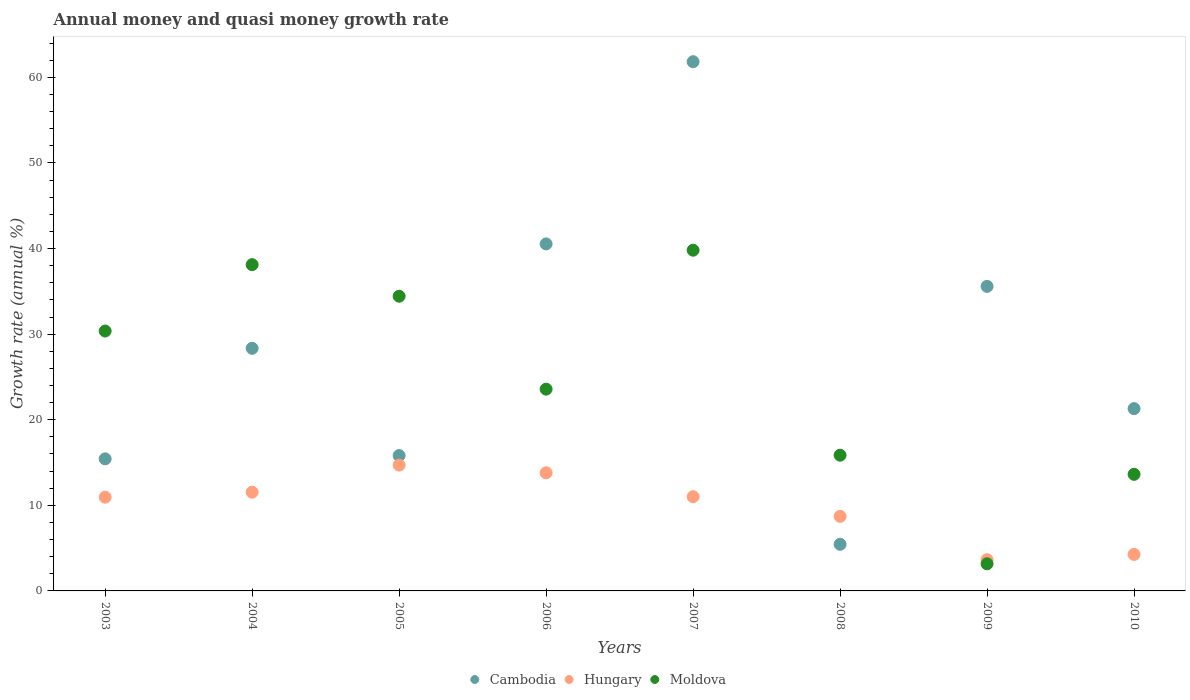Is the number of dotlines equal to the number of legend labels?
Provide a succinct answer. Yes. What is the growth rate in Moldova in 2006?
Your answer should be compact. 23.58. Across all years, what is the maximum growth rate in Cambodia?
Ensure brevity in your answer.  61.84. Across all years, what is the minimum growth rate in Hungary?
Keep it short and to the point. 3.65. In which year was the growth rate in Moldova minimum?
Your answer should be very brief. 2009. What is the total growth rate in Cambodia in the graph?
Keep it short and to the point. 224.31. What is the difference between the growth rate in Cambodia in 2006 and that in 2010?
Provide a succinct answer. 19.25. What is the difference between the growth rate in Hungary in 2009 and the growth rate in Moldova in 2008?
Give a very brief answer. -12.21. What is the average growth rate in Moldova per year?
Your answer should be very brief. 24.87. In the year 2005, what is the difference between the growth rate in Hungary and growth rate in Cambodia?
Ensure brevity in your answer.  -1.12. In how many years, is the growth rate in Moldova greater than 18 %?
Your answer should be very brief. 5. What is the ratio of the growth rate in Hungary in 2006 to that in 2010?
Your response must be concise. 3.23. What is the difference between the highest and the second highest growth rate in Moldova?
Give a very brief answer. 1.69. What is the difference between the highest and the lowest growth rate in Cambodia?
Your response must be concise. 56.39. Is the sum of the growth rate in Moldova in 2003 and 2010 greater than the maximum growth rate in Cambodia across all years?
Your answer should be very brief. No. Does the growth rate in Cambodia monotonically increase over the years?
Your answer should be compact. No. How many dotlines are there?
Keep it short and to the point. 3. Are the values on the major ticks of Y-axis written in scientific E-notation?
Keep it short and to the point. No. Where does the legend appear in the graph?
Ensure brevity in your answer.  Bottom center. What is the title of the graph?
Your answer should be compact. Annual money and quasi money growth rate. Does "Suriname" appear as one of the legend labels in the graph?
Ensure brevity in your answer.  No. What is the label or title of the Y-axis?
Make the answer very short. Growth rate (annual %). What is the Growth rate (annual %) in Cambodia in 2003?
Offer a terse response. 15.43. What is the Growth rate (annual %) of Hungary in 2003?
Make the answer very short. 10.95. What is the Growth rate (annual %) in Moldova in 2003?
Keep it short and to the point. 30.37. What is the Growth rate (annual %) of Cambodia in 2004?
Keep it short and to the point. 28.35. What is the Growth rate (annual %) in Hungary in 2004?
Ensure brevity in your answer.  11.54. What is the Growth rate (annual %) in Moldova in 2004?
Provide a succinct answer. 38.12. What is the Growth rate (annual %) in Cambodia in 2005?
Your answer should be compact. 15.82. What is the Growth rate (annual %) in Hungary in 2005?
Offer a terse response. 14.7. What is the Growth rate (annual %) in Moldova in 2005?
Keep it short and to the point. 34.43. What is the Growth rate (annual %) in Cambodia in 2006?
Ensure brevity in your answer.  40.55. What is the Growth rate (annual %) in Hungary in 2006?
Keep it short and to the point. 13.8. What is the Growth rate (annual %) in Moldova in 2006?
Provide a short and direct response. 23.58. What is the Growth rate (annual %) of Cambodia in 2007?
Your response must be concise. 61.84. What is the Growth rate (annual %) of Hungary in 2007?
Offer a very short reply. 11.01. What is the Growth rate (annual %) of Moldova in 2007?
Offer a very short reply. 39.81. What is the Growth rate (annual %) in Cambodia in 2008?
Ensure brevity in your answer.  5.45. What is the Growth rate (annual %) in Hungary in 2008?
Offer a very short reply. 8.71. What is the Growth rate (annual %) of Moldova in 2008?
Provide a short and direct response. 15.86. What is the Growth rate (annual %) of Cambodia in 2009?
Your answer should be compact. 35.58. What is the Growth rate (annual %) in Hungary in 2009?
Your answer should be very brief. 3.65. What is the Growth rate (annual %) of Moldova in 2009?
Give a very brief answer. 3.17. What is the Growth rate (annual %) in Cambodia in 2010?
Provide a succinct answer. 21.3. What is the Growth rate (annual %) in Hungary in 2010?
Your answer should be very brief. 4.27. What is the Growth rate (annual %) of Moldova in 2010?
Provide a succinct answer. 13.62. Across all years, what is the maximum Growth rate (annual %) of Cambodia?
Your answer should be compact. 61.84. Across all years, what is the maximum Growth rate (annual %) in Hungary?
Offer a terse response. 14.7. Across all years, what is the maximum Growth rate (annual %) in Moldova?
Offer a terse response. 39.81. Across all years, what is the minimum Growth rate (annual %) in Cambodia?
Keep it short and to the point. 5.45. Across all years, what is the minimum Growth rate (annual %) of Hungary?
Your answer should be very brief. 3.65. Across all years, what is the minimum Growth rate (annual %) of Moldova?
Ensure brevity in your answer.  3.17. What is the total Growth rate (annual %) in Cambodia in the graph?
Offer a terse response. 224.31. What is the total Growth rate (annual %) in Hungary in the graph?
Offer a very short reply. 78.63. What is the total Growth rate (annual %) of Moldova in the graph?
Your response must be concise. 198.96. What is the difference between the Growth rate (annual %) in Cambodia in 2003 and that in 2004?
Your answer should be very brief. -12.92. What is the difference between the Growth rate (annual %) in Hungary in 2003 and that in 2004?
Give a very brief answer. -0.59. What is the difference between the Growth rate (annual %) of Moldova in 2003 and that in 2004?
Your answer should be very brief. -7.76. What is the difference between the Growth rate (annual %) of Cambodia in 2003 and that in 2005?
Ensure brevity in your answer.  -0.38. What is the difference between the Growth rate (annual %) of Hungary in 2003 and that in 2005?
Provide a short and direct response. -3.75. What is the difference between the Growth rate (annual %) in Moldova in 2003 and that in 2005?
Make the answer very short. -4.07. What is the difference between the Growth rate (annual %) in Cambodia in 2003 and that in 2006?
Provide a succinct answer. -25.11. What is the difference between the Growth rate (annual %) of Hungary in 2003 and that in 2006?
Ensure brevity in your answer.  -2.85. What is the difference between the Growth rate (annual %) in Moldova in 2003 and that in 2006?
Provide a succinct answer. 6.79. What is the difference between the Growth rate (annual %) of Cambodia in 2003 and that in 2007?
Your response must be concise. -46.4. What is the difference between the Growth rate (annual %) of Hungary in 2003 and that in 2007?
Your response must be concise. -0.06. What is the difference between the Growth rate (annual %) in Moldova in 2003 and that in 2007?
Keep it short and to the point. -9.44. What is the difference between the Growth rate (annual %) in Cambodia in 2003 and that in 2008?
Offer a very short reply. 9.99. What is the difference between the Growth rate (annual %) of Hungary in 2003 and that in 2008?
Ensure brevity in your answer.  2.24. What is the difference between the Growth rate (annual %) in Moldova in 2003 and that in 2008?
Offer a terse response. 14.51. What is the difference between the Growth rate (annual %) of Cambodia in 2003 and that in 2009?
Make the answer very short. -20.15. What is the difference between the Growth rate (annual %) of Hungary in 2003 and that in 2009?
Ensure brevity in your answer.  7.3. What is the difference between the Growth rate (annual %) of Moldova in 2003 and that in 2009?
Provide a succinct answer. 27.2. What is the difference between the Growth rate (annual %) in Cambodia in 2003 and that in 2010?
Provide a short and direct response. -5.87. What is the difference between the Growth rate (annual %) in Hungary in 2003 and that in 2010?
Make the answer very short. 6.69. What is the difference between the Growth rate (annual %) of Moldova in 2003 and that in 2010?
Give a very brief answer. 16.74. What is the difference between the Growth rate (annual %) of Cambodia in 2004 and that in 2005?
Your answer should be very brief. 12.53. What is the difference between the Growth rate (annual %) in Hungary in 2004 and that in 2005?
Provide a succinct answer. -3.16. What is the difference between the Growth rate (annual %) of Moldova in 2004 and that in 2005?
Offer a terse response. 3.69. What is the difference between the Growth rate (annual %) of Cambodia in 2004 and that in 2006?
Ensure brevity in your answer.  -12.2. What is the difference between the Growth rate (annual %) in Hungary in 2004 and that in 2006?
Make the answer very short. -2.27. What is the difference between the Growth rate (annual %) in Moldova in 2004 and that in 2006?
Provide a succinct answer. 14.55. What is the difference between the Growth rate (annual %) in Cambodia in 2004 and that in 2007?
Make the answer very short. -33.49. What is the difference between the Growth rate (annual %) of Hungary in 2004 and that in 2007?
Ensure brevity in your answer.  0.53. What is the difference between the Growth rate (annual %) of Moldova in 2004 and that in 2007?
Provide a succinct answer. -1.69. What is the difference between the Growth rate (annual %) of Cambodia in 2004 and that in 2008?
Your answer should be very brief. 22.9. What is the difference between the Growth rate (annual %) of Hungary in 2004 and that in 2008?
Your response must be concise. 2.83. What is the difference between the Growth rate (annual %) in Moldova in 2004 and that in 2008?
Your answer should be very brief. 22.26. What is the difference between the Growth rate (annual %) in Cambodia in 2004 and that in 2009?
Offer a terse response. -7.23. What is the difference between the Growth rate (annual %) in Hungary in 2004 and that in 2009?
Ensure brevity in your answer.  7.89. What is the difference between the Growth rate (annual %) of Moldova in 2004 and that in 2009?
Provide a succinct answer. 34.95. What is the difference between the Growth rate (annual %) in Cambodia in 2004 and that in 2010?
Provide a short and direct response. 7.05. What is the difference between the Growth rate (annual %) of Hungary in 2004 and that in 2010?
Make the answer very short. 7.27. What is the difference between the Growth rate (annual %) in Moldova in 2004 and that in 2010?
Your answer should be compact. 24.5. What is the difference between the Growth rate (annual %) of Cambodia in 2005 and that in 2006?
Provide a succinct answer. -24.73. What is the difference between the Growth rate (annual %) in Hungary in 2005 and that in 2006?
Ensure brevity in your answer.  0.9. What is the difference between the Growth rate (annual %) in Moldova in 2005 and that in 2006?
Make the answer very short. 10.86. What is the difference between the Growth rate (annual %) of Cambodia in 2005 and that in 2007?
Keep it short and to the point. -46.02. What is the difference between the Growth rate (annual %) of Hungary in 2005 and that in 2007?
Ensure brevity in your answer.  3.69. What is the difference between the Growth rate (annual %) of Moldova in 2005 and that in 2007?
Make the answer very short. -5.38. What is the difference between the Growth rate (annual %) in Cambodia in 2005 and that in 2008?
Your response must be concise. 10.37. What is the difference between the Growth rate (annual %) in Hungary in 2005 and that in 2008?
Ensure brevity in your answer.  5.99. What is the difference between the Growth rate (annual %) of Moldova in 2005 and that in 2008?
Offer a terse response. 18.57. What is the difference between the Growth rate (annual %) of Cambodia in 2005 and that in 2009?
Your response must be concise. -19.77. What is the difference between the Growth rate (annual %) of Hungary in 2005 and that in 2009?
Ensure brevity in your answer.  11.05. What is the difference between the Growth rate (annual %) of Moldova in 2005 and that in 2009?
Your answer should be compact. 31.27. What is the difference between the Growth rate (annual %) of Cambodia in 2005 and that in 2010?
Make the answer very short. -5.48. What is the difference between the Growth rate (annual %) of Hungary in 2005 and that in 2010?
Your answer should be very brief. 10.43. What is the difference between the Growth rate (annual %) of Moldova in 2005 and that in 2010?
Make the answer very short. 20.81. What is the difference between the Growth rate (annual %) in Cambodia in 2006 and that in 2007?
Make the answer very short. -21.29. What is the difference between the Growth rate (annual %) in Hungary in 2006 and that in 2007?
Offer a very short reply. 2.79. What is the difference between the Growth rate (annual %) in Moldova in 2006 and that in 2007?
Your answer should be compact. -16.23. What is the difference between the Growth rate (annual %) in Cambodia in 2006 and that in 2008?
Give a very brief answer. 35.1. What is the difference between the Growth rate (annual %) in Hungary in 2006 and that in 2008?
Offer a very short reply. 5.09. What is the difference between the Growth rate (annual %) in Moldova in 2006 and that in 2008?
Offer a terse response. 7.72. What is the difference between the Growth rate (annual %) of Cambodia in 2006 and that in 2009?
Your answer should be compact. 4.96. What is the difference between the Growth rate (annual %) in Hungary in 2006 and that in 2009?
Ensure brevity in your answer.  10.15. What is the difference between the Growth rate (annual %) of Moldova in 2006 and that in 2009?
Give a very brief answer. 20.41. What is the difference between the Growth rate (annual %) of Cambodia in 2006 and that in 2010?
Your response must be concise. 19.25. What is the difference between the Growth rate (annual %) in Hungary in 2006 and that in 2010?
Make the answer very short. 9.54. What is the difference between the Growth rate (annual %) of Moldova in 2006 and that in 2010?
Ensure brevity in your answer.  9.95. What is the difference between the Growth rate (annual %) of Cambodia in 2007 and that in 2008?
Keep it short and to the point. 56.39. What is the difference between the Growth rate (annual %) in Hungary in 2007 and that in 2008?
Keep it short and to the point. 2.3. What is the difference between the Growth rate (annual %) in Moldova in 2007 and that in 2008?
Provide a short and direct response. 23.95. What is the difference between the Growth rate (annual %) of Cambodia in 2007 and that in 2009?
Offer a terse response. 26.25. What is the difference between the Growth rate (annual %) of Hungary in 2007 and that in 2009?
Your answer should be very brief. 7.36. What is the difference between the Growth rate (annual %) of Moldova in 2007 and that in 2009?
Keep it short and to the point. 36.64. What is the difference between the Growth rate (annual %) of Cambodia in 2007 and that in 2010?
Your answer should be very brief. 40.54. What is the difference between the Growth rate (annual %) of Hungary in 2007 and that in 2010?
Provide a succinct answer. 6.74. What is the difference between the Growth rate (annual %) of Moldova in 2007 and that in 2010?
Provide a succinct answer. 26.19. What is the difference between the Growth rate (annual %) in Cambodia in 2008 and that in 2009?
Your response must be concise. -30.14. What is the difference between the Growth rate (annual %) in Hungary in 2008 and that in 2009?
Give a very brief answer. 5.06. What is the difference between the Growth rate (annual %) of Moldova in 2008 and that in 2009?
Give a very brief answer. 12.69. What is the difference between the Growth rate (annual %) of Cambodia in 2008 and that in 2010?
Your answer should be very brief. -15.85. What is the difference between the Growth rate (annual %) of Hungary in 2008 and that in 2010?
Offer a terse response. 4.44. What is the difference between the Growth rate (annual %) of Moldova in 2008 and that in 2010?
Offer a terse response. 2.24. What is the difference between the Growth rate (annual %) in Cambodia in 2009 and that in 2010?
Give a very brief answer. 14.28. What is the difference between the Growth rate (annual %) of Hungary in 2009 and that in 2010?
Make the answer very short. -0.62. What is the difference between the Growth rate (annual %) in Moldova in 2009 and that in 2010?
Ensure brevity in your answer.  -10.45. What is the difference between the Growth rate (annual %) in Cambodia in 2003 and the Growth rate (annual %) in Hungary in 2004?
Make the answer very short. 3.89. What is the difference between the Growth rate (annual %) in Cambodia in 2003 and the Growth rate (annual %) in Moldova in 2004?
Your answer should be compact. -22.69. What is the difference between the Growth rate (annual %) in Hungary in 2003 and the Growth rate (annual %) in Moldova in 2004?
Give a very brief answer. -27.17. What is the difference between the Growth rate (annual %) of Cambodia in 2003 and the Growth rate (annual %) of Hungary in 2005?
Make the answer very short. 0.73. What is the difference between the Growth rate (annual %) in Cambodia in 2003 and the Growth rate (annual %) in Moldova in 2005?
Provide a short and direct response. -19. What is the difference between the Growth rate (annual %) of Hungary in 2003 and the Growth rate (annual %) of Moldova in 2005?
Give a very brief answer. -23.48. What is the difference between the Growth rate (annual %) in Cambodia in 2003 and the Growth rate (annual %) in Hungary in 2006?
Provide a short and direct response. 1.63. What is the difference between the Growth rate (annual %) in Cambodia in 2003 and the Growth rate (annual %) in Moldova in 2006?
Provide a short and direct response. -8.14. What is the difference between the Growth rate (annual %) of Hungary in 2003 and the Growth rate (annual %) of Moldova in 2006?
Provide a succinct answer. -12.62. What is the difference between the Growth rate (annual %) of Cambodia in 2003 and the Growth rate (annual %) of Hungary in 2007?
Your answer should be compact. 4.42. What is the difference between the Growth rate (annual %) of Cambodia in 2003 and the Growth rate (annual %) of Moldova in 2007?
Make the answer very short. -24.38. What is the difference between the Growth rate (annual %) in Hungary in 2003 and the Growth rate (annual %) in Moldova in 2007?
Offer a terse response. -28.86. What is the difference between the Growth rate (annual %) in Cambodia in 2003 and the Growth rate (annual %) in Hungary in 2008?
Ensure brevity in your answer.  6.72. What is the difference between the Growth rate (annual %) of Cambodia in 2003 and the Growth rate (annual %) of Moldova in 2008?
Give a very brief answer. -0.43. What is the difference between the Growth rate (annual %) in Hungary in 2003 and the Growth rate (annual %) in Moldova in 2008?
Ensure brevity in your answer.  -4.91. What is the difference between the Growth rate (annual %) of Cambodia in 2003 and the Growth rate (annual %) of Hungary in 2009?
Your answer should be very brief. 11.78. What is the difference between the Growth rate (annual %) in Cambodia in 2003 and the Growth rate (annual %) in Moldova in 2009?
Your answer should be compact. 12.26. What is the difference between the Growth rate (annual %) of Hungary in 2003 and the Growth rate (annual %) of Moldova in 2009?
Give a very brief answer. 7.78. What is the difference between the Growth rate (annual %) of Cambodia in 2003 and the Growth rate (annual %) of Hungary in 2010?
Your answer should be compact. 11.17. What is the difference between the Growth rate (annual %) in Cambodia in 2003 and the Growth rate (annual %) in Moldova in 2010?
Your answer should be compact. 1.81. What is the difference between the Growth rate (annual %) of Hungary in 2003 and the Growth rate (annual %) of Moldova in 2010?
Ensure brevity in your answer.  -2.67. What is the difference between the Growth rate (annual %) in Cambodia in 2004 and the Growth rate (annual %) in Hungary in 2005?
Provide a succinct answer. 13.65. What is the difference between the Growth rate (annual %) of Cambodia in 2004 and the Growth rate (annual %) of Moldova in 2005?
Your answer should be compact. -6.08. What is the difference between the Growth rate (annual %) of Hungary in 2004 and the Growth rate (annual %) of Moldova in 2005?
Make the answer very short. -22.9. What is the difference between the Growth rate (annual %) in Cambodia in 2004 and the Growth rate (annual %) in Hungary in 2006?
Offer a terse response. 14.55. What is the difference between the Growth rate (annual %) in Cambodia in 2004 and the Growth rate (annual %) in Moldova in 2006?
Keep it short and to the point. 4.77. What is the difference between the Growth rate (annual %) in Hungary in 2004 and the Growth rate (annual %) in Moldova in 2006?
Keep it short and to the point. -12.04. What is the difference between the Growth rate (annual %) of Cambodia in 2004 and the Growth rate (annual %) of Hungary in 2007?
Provide a succinct answer. 17.34. What is the difference between the Growth rate (annual %) of Cambodia in 2004 and the Growth rate (annual %) of Moldova in 2007?
Give a very brief answer. -11.46. What is the difference between the Growth rate (annual %) in Hungary in 2004 and the Growth rate (annual %) in Moldova in 2007?
Provide a short and direct response. -28.27. What is the difference between the Growth rate (annual %) of Cambodia in 2004 and the Growth rate (annual %) of Hungary in 2008?
Your answer should be very brief. 19.64. What is the difference between the Growth rate (annual %) in Cambodia in 2004 and the Growth rate (annual %) in Moldova in 2008?
Ensure brevity in your answer.  12.49. What is the difference between the Growth rate (annual %) of Hungary in 2004 and the Growth rate (annual %) of Moldova in 2008?
Your response must be concise. -4.32. What is the difference between the Growth rate (annual %) of Cambodia in 2004 and the Growth rate (annual %) of Hungary in 2009?
Keep it short and to the point. 24.7. What is the difference between the Growth rate (annual %) in Cambodia in 2004 and the Growth rate (annual %) in Moldova in 2009?
Your answer should be compact. 25.18. What is the difference between the Growth rate (annual %) of Hungary in 2004 and the Growth rate (annual %) of Moldova in 2009?
Give a very brief answer. 8.37. What is the difference between the Growth rate (annual %) of Cambodia in 2004 and the Growth rate (annual %) of Hungary in 2010?
Give a very brief answer. 24.08. What is the difference between the Growth rate (annual %) in Cambodia in 2004 and the Growth rate (annual %) in Moldova in 2010?
Offer a terse response. 14.73. What is the difference between the Growth rate (annual %) of Hungary in 2004 and the Growth rate (annual %) of Moldova in 2010?
Provide a short and direct response. -2.08. What is the difference between the Growth rate (annual %) of Cambodia in 2005 and the Growth rate (annual %) of Hungary in 2006?
Your response must be concise. 2.01. What is the difference between the Growth rate (annual %) in Cambodia in 2005 and the Growth rate (annual %) in Moldova in 2006?
Ensure brevity in your answer.  -7.76. What is the difference between the Growth rate (annual %) of Hungary in 2005 and the Growth rate (annual %) of Moldova in 2006?
Provide a succinct answer. -8.88. What is the difference between the Growth rate (annual %) in Cambodia in 2005 and the Growth rate (annual %) in Hungary in 2007?
Give a very brief answer. 4.8. What is the difference between the Growth rate (annual %) of Cambodia in 2005 and the Growth rate (annual %) of Moldova in 2007?
Your answer should be very brief. -23.99. What is the difference between the Growth rate (annual %) of Hungary in 2005 and the Growth rate (annual %) of Moldova in 2007?
Your answer should be very brief. -25.11. What is the difference between the Growth rate (annual %) of Cambodia in 2005 and the Growth rate (annual %) of Hungary in 2008?
Your answer should be compact. 7.11. What is the difference between the Growth rate (annual %) in Cambodia in 2005 and the Growth rate (annual %) in Moldova in 2008?
Ensure brevity in your answer.  -0.04. What is the difference between the Growth rate (annual %) of Hungary in 2005 and the Growth rate (annual %) of Moldova in 2008?
Your answer should be very brief. -1.16. What is the difference between the Growth rate (annual %) of Cambodia in 2005 and the Growth rate (annual %) of Hungary in 2009?
Your response must be concise. 12.17. What is the difference between the Growth rate (annual %) of Cambodia in 2005 and the Growth rate (annual %) of Moldova in 2009?
Provide a short and direct response. 12.65. What is the difference between the Growth rate (annual %) of Hungary in 2005 and the Growth rate (annual %) of Moldova in 2009?
Provide a succinct answer. 11.53. What is the difference between the Growth rate (annual %) in Cambodia in 2005 and the Growth rate (annual %) in Hungary in 2010?
Your answer should be very brief. 11.55. What is the difference between the Growth rate (annual %) of Cambodia in 2005 and the Growth rate (annual %) of Moldova in 2010?
Provide a short and direct response. 2.19. What is the difference between the Growth rate (annual %) in Hungary in 2005 and the Growth rate (annual %) in Moldova in 2010?
Provide a succinct answer. 1.08. What is the difference between the Growth rate (annual %) in Cambodia in 2006 and the Growth rate (annual %) in Hungary in 2007?
Offer a terse response. 29.53. What is the difference between the Growth rate (annual %) of Cambodia in 2006 and the Growth rate (annual %) of Moldova in 2007?
Your answer should be compact. 0.74. What is the difference between the Growth rate (annual %) of Hungary in 2006 and the Growth rate (annual %) of Moldova in 2007?
Give a very brief answer. -26.01. What is the difference between the Growth rate (annual %) of Cambodia in 2006 and the Growth rate (annual %) of Hungary in 2008?
Make the answer very short. 31.84. What is the difference between the Growth rate (annual %) in Cambodia in 2006 and the Growth rate (annual %) in Moldova in 2008?
Make the answer very short. 24.69. What is the difference between the Growth rate (annual %) in Hungary in 2006 and the Growth rate (annual %) in Moldova in 2008?
Provide a short and direct response. -2.06. What is the difference between the Growth rate (annual %) of Cambodia in 2006 and the Growth rate (annual %) of Hungary in 2009?
Your answer should be very brief. 36.9. What is the difference between the Growth rate (annual %) of Cambodia in 2006 and the Growth rate (annual %) of Moldova in 2009?
Ensure brevity in your answer.  37.38. What is the difference between the Growth rate (annual %) of Hungary in 2006 and the Growth rate (annual %) of Moldova in 2009?
Keep it short and to the point. 10.63. What is the difference between the Growth rate (annual %) in Cambodia in 2006 and the Growth rate (annual %) in Hungary in 2010?
Your answer should be very brief. 36.28. What is the difference between the Growth rate (annual %) in Cambodia in 2006 and the Growth rate (annual %) in Moldova in 2010?
Your response must be concise. 26.92. What is the difference between the Growth rate (annual %) in Hungary in 2006 and the Growth rate (annual %) in Moldova in 2010?
Provide a short and direct response. 0.18. What is the difference between the Growth rate (annual %) in Cambodia in 2007 and the Growth rate (annual %) in Hungary in 2008?
Keep it short and to the point. 53.13. What is the difference between the Growth rate (annual %) of Cambodia in 2007 and the Growth rate (annual %) of Moldova in 2008?
Offer a terse response. 45.98. What is the difference between the Growth rate (annual %) of Hungary in 2007 and the Growth rate (annual %) of Moldova in 2008?
Your response must be concise. -4.85. What is the difference between the Growth rate (annual %) in Cambodia in 2007 and the Growth rate (annual %) in Hungary in 2009?
Give a very brief answer. 58.19. What is the difference between the Growth rate (annual %) of Cambodia in 2007 and the Growth rate (annual %) of Moldova in 2009?
Offer a terse response. 58.67. What is the difference between the Growth rate (annual %) in Hungary in 2007 and the Growth rate (annual %) in Moldova in 2009?
Offer a very short reply. 7.84. What is the difference between the Growth rate (annual %) of Cambodia in 2007 and the Growth rate (annual %) of Hungary in 2010?
Your response must be concise. 57.57. What is the difference between the Growth rate (annual %) in Cambodia in 2007 and the Growth rate (annual %) in Moldova in 2010?
Your answer should be very brief. 48.21. What is the difference between the Growth rate (annual %) in Hungary in 2007 and the Growth rate (annual %) in Moldova in 2010?
Your answer should be compact. -2.61. What is the difference between the Growth rate (annual %) in Cambodia in 2008 and the Growth rate (annual %) in Hungary in 2009?
Offer a terse response. 1.8. What is the difference between the Growth rate (annual %) of Cambodia in 2008 and the Growth rate (annual %) of Moldova in 2009?
Your answer should be very brief. 2.28. What is the difference between the Growth rate (annual %) of Hungary in 2008 and the Growth rate (annual %) of Moldova in 2009?
Keep it short and to the point. 5.54. What is the difference between the Growth rate (annual %) of Cambodia in 2008 and the Growth rate (annual %) of Hungary in 2010?
Provide a succinct answer. 1.18. What is the difference between the Growth rate (annual %) of Cambodia in 2008 and the Growth rate (annual %) of Moldova in 2010?
Keep it short and to the point. -8.18. What is the difference between the Growth rate (annual %) of Hungary in 2008 and the Growth rate (annual %) of Moldova in 2010?
Your answer should be compact. -4.91. What is the difference between the Growth rate (annual %) of Cambodia in 2009 and the Growth rate (annual %) of Hungary in 2010?
Offer a very short reply. 31.32. What is the difference between the Growth rate (annual %) in Cambodia in 2009 and the Growth rate (annual %) in Moldova in 2010?
Your answer should be compact. 21.96. What is the difference between the Growth rate (annual %) of Hungary in 2009 and the Growth rate (annual %) of Moldova in 2010?
Your answer should be very brief. -9.97. What is the average Growth rate (annual %) of Cambodia per year?
Your answer should be compact. 28.04. What is the average Growth rate (annual %) in Hungary per year?
Your answer should be very brief. 9.83. What is the average Growth rate (annual %) in Moldova per year?
Your answer should be very brief. 24.87. In the year 2003, what is the difference between the Growth rate (annual %) of Cambodia and Growth rate (annual %) of Hungary?
Your answer should be compact. 4.48. In the year 2003, what is the difference between the Growth rate (annual %) of Cambodia and Growth rate (annual %) of Moldova?
Offer a very short reply. -14.93. In the year 2003, what is the difference between the Growth rate (annual %) of Hungary and Growth rate (annual %) of Moldova?
Ensure brevity in your answer.  -19.41. In the year 2004, what is the difference between the Growth rate (annual %) of Cambodia and Growth rate (annual %) of Hungary?
Make the answer very short. 16.81. In the year 2004, what is the difference between the Growth rate (annual %) of Cambodia and Growth rate (annual %) of Moldova?
Give a very brief answer. -9.77. In the year 2004, what is the difference between the Growth rate (annual %) of Hungary and Growth rate (annual %) of Moldova?
Offer a terse response. -26.58. In the year 2005, what is the difference between the Growth rate (annual %) of Cambodia and Growth rate (annual %) of Hungary?
Provide a short and direct response. 1.12. In the year 2005, what is the difference between the Growth rate (annual %) in Cambodia and Growth rate (annual %) in Moldova?
Ensure brevity in your answer.  -18.62. In the year 2005, what is the difference between the Growth rate (annual %) of Hungary and Growth rate (annual %) of Moldova?
Your answer should be compact. -19.73. In the year 2006, what is the difference between the Growth rate (annual %) of Cambodia and Growth rate (annual %) of Hungary?
Provide a succinct answer. 26.74. In the year 2006, what is the difference between the Growth rate (annual %) of Cambodia and Growth rate (annual %) of Moldova?
Your response must be concise. 16.97. In the year 2006, what is the difference between the Growth rate (annual %) in Hungary and Growth rate (annual %) in Moldova?
Offer a terse response. -9.77. In the year 2007, what is the difference between the Growth rate (annual %) of Cambodia and Growth rate (annual %) of Hungary?
Keep it short and to the point. 50.82. In the year 2007, what is the difference between the Growth rate (annual %) of Cambodia and Growth rate (annual %) of Moldova?
Make the answer very short. 22.03. In the year 2007, what is the difference between the Growth rate (annual %) in Hungary and Growth rate (annual %) in Moldova?
Provide a short and direct response. -28.8. In the year 2008, what is the difference between the Growth rate (annual %) of Cambodia and Growth rate (annual %) of Hungary?
Your response must be concise. -3.26. In the year 2008, what is the difference between the Growth rate (annual %) in Cambodia and Growth rate (annual %) in Moldova?
Offer a terse response. -10.41. In the year 2008, what is the difference between the Growth rate (annual %) of Hungary and Growth rate (annual %) of Moldova?
Provide a short and direct response. -7.15. In the year 2009, what is the difference between the Growth rate (annual %) of Cambodia and Growth rate (annual %) of Hungary?
Your answer should be very brief. 31.93. In the year 2009, what is the difference between the Growth rate (annual %) in Cambodia and Growth rate (annual %) in Moldova?
Provide a short and direct response. 32.41. In the year 2009, what is the difference between the Growth rate (annual %) in Hungary and Growth rate (annual %) in Moldova?
Make the answer very short. 0.48. In the year 2010, what is the difference between the Growth rate (annual %) of Cambodia and Growth rate (annual %) of Hungary?
Offer a terse response. 17.03. In the year 2010, what is the difference between the Growth rate (annual %) in Cambodia and Growth rate (annual %) in Moldova?
Make the answer very short. 7.68. In the year 2010, what is the difference between the Growth rate (annual %) in Hungary and Growth rate (annual %) in Moldova?
Keep it short and to the point. -9.35. What is the ratio of the Growth rate (annual %) in Cambodia in 2003 to that in 2004?
Offer a terse response. 0.54. What is the ratio of the Growth rate (annual %) in Hungary in 2003 to that in 2004?
Your answer should be compact. 0.95. What is the ratio of the Growth rate (annual %) in Moldova in 2003 to that in 2004?
Offer a terse response. 0.8. What is the ratio of the Growth rate (annual %) in Cambodia in 2003 to that in 2005?
Keep it short and to the point. 0.98. What is the ratio of the Growth rate (annual %) in Hungary in 2003 to that in 2005?
Your answer should be very brief. 0.74. What is the ratio of the Growth rate (annual %) of Moldova in 2003 to that in 2005?
Ensure brevity in your answer.  0.88. What is the ratio of the Growth rate (annual %) of Cambodia in 2003 to that in 2006?
Offer a terse response. 0.38. What is the ratio of the Growth rate (annual %) of Hungary in 2003 to that in 2006?
Make the answer very short. 0.79. What is the ratio of the Growth rate (annual %) in Moldova in 2003 to that in 2006?
Your answer should be compact. 1.29. What is the ratio of the Growth rate (annual %) in Cambodia in 2003 to that in 2007?
Ensure brevity in your answer.  0.25. What is the ratio of the Growth rate (annual %) in Moldova in 2003 to that in 2007?
Ensure brevity in your answer.  0.76. What is the ratio of the Growth rate (annual %) of Cambodia in 2003 to that in 2008?
Your response must be concise. 2.83. What is the ratio of the Growth rate (annual %) of Hungary in 2003 to that in 2008?
Your answer should be compact. 1.26. What is the ratio of the Growth rate (annual %) of Moldova in 2003 to that in 2008?
Offer a terse response. 1.91. What is the ratio of the Growth rate (annual %) in Cambodia in 2003 to that in 2009?
Provide a succinct answer. 0.43. What is the ratio of the Growth rate (annual %) in Hungary in 2003 to that in 2009?
Offer a terse response. 3. What is the ratio of the Growth rate (annual %) of Moldova in 2003 to that in 2009?
Keep it short and to the point. 9.58. What is the ratio of the Growth rate (annual %) in Cambodia in 2003 to that in 2010?
Your response must be concise. 0.72. What is the ratio of the Growth rate (annual %) of Hungary in 2003 to that in 2010?
Your answer should be very brief. 2.57. What is the ratio of the Growth rate (annual %) of Moldova in 2003 to that in 2010?
Your answer should be compact. 2.23. What is the ratio of the Growth rate (annual %) of Cambodia in 2004 to that in 2005?
Offer a very short reply. 1.79. What is the ratio of the Growth rate (annual %) of Hungary in 2004 to that in 2005?
Keep it short and to the point. 0.78. What is the ratio of the Growth rate (annual %) in Moldova in 2004 to that in 2005?
Make the answer very short. 1.11. What is the ratio of the Growth rate (annual %) of Cambodia in 2004 to that in 2006?
Give a very brief answer. 0.7. What is the ratio of the Growth rate (annual %) of Hungary in 2004 to that in 2006?
Make the answer very short. 0.84. What is the ratio of the Growth rate (annual %) in Moldova in 2004 to that in 2006?
Offer a terse response. 1.62. What is the ratio of the Growth rate (annual %) in Cambodia in 2004 to that in 2007?
Give a very brief answer. 0.46. What is the ratio of the Growth rate (annual %) of Hungary in 2004 to that in 2007?
Ensure brevity in your answer.  1.05. What is the ratio of the Growth rate (annual %) of Moldova in 2004 to that in 2007?
Ensure brevity in your answer.  0.96. What is the ratio of the Growth rate (annual %) of Cambodia in 2004 to that in 2008?
Keep it short and to the point. 5.21. What is the ratio of the Growth rate (annual %) in Hungary in 2004 to that in 2008?
Your answer should be compact. 1.32. What is the ratio of the Growth rate (annual %) in Moldova in 2004 to that in 2008?
Ensure brevity in your answer.  2.4. What is the ratio of the Growth rate (annual %) of Cambodia in 2004 to that in 2009?
Your response must be concise. 0.8. What is the ratio of the Growth rate (annual %) of Hungary in 2004 to that in 2009?
Offer a very short reply. 3.16. What is the ratio of the Growth rate (annual %) in Moldova in 2004 to that in 2009?
Make the answer very short. 12.03. What is the ratio of the Growth rate (annual %) in Cambodia in 2004 to that in 2010?
Keep it short and to the point. 1.33. What is the ratio of the Growth rate (annual %) of Hungary in 2004 to that in 2010?
Your response must be concise. 2.7. What is the ratio of the Growth rate (annual %) of Moldova in 2004 to that in 2010?
Provide a short and direct response. 2.8. What is the ratio of the Growth rate (annual %) in Cambodia in 2005 to that in 2006?
Offer a very short reply. 0.39. What is the ratio of the Growth rate (annual %) in Hungary in 2005 to that in 2006?
Your answer should be compact. 1.06. What is the ratio of the Growth rate (annual %) of Moldova in 2005 to that in 2006?
Your response must be concise. 1.46. What is the ratio of the Growth rate (annual %) of Cambodia in 2005 to that in 2007?
Provide a succinct answer. 0.26. What is the ratio of the Growth rate (annual %) in Hungary in 2005 to that in 2007?
Your response must be concise. 1.33. What is the ratio of the Growth rate (annual %) in Moldova in 2005 to that in 2007?
Provide a succinct answer. 0.86. What is the ratio of the Growth rate (annual %) in Cambodia in 2005 to that in 2008?
Provide a succinct answer. 2.9. What is the ratio of the Growth rate (annual %) of Hungary in 2005 to that in 2008?
Offer a terse response. 1.69. What is the ratio of the Growth rate (annual %) in Moldova in 2005 to that in 2008?
Your answer should be compact. 2.17. What is the ratio of the Growth rate (annual %) in Cambodia in 2005 to that in 2009?
Make the answer very short. 0.44. What is the ratio of the Growth rate (annual %) in Hungary in 2005 to that in 2009?
Your answer should be compact. 4.03. What is the ratio of the Growth rate (annual %) of Moldova in 2005 to that in 2009?
Offer a terse response. 10.87. What is the ratio of the Growth rate (annual %) of Cambodia in 2005 to that in 2010?
Your response must be concise. 0.74. What is the ratio of the Growth rate (annual %) in Hungary in 2005 to that in 2010?
Give a very brief answer. 3.44. What is the ratio of the Growth rate (annual %) of Moldova in 2005 to that in 2010?
Ensure brevity in your answer.  2.53. What is the ratio of the Growth rate (annual %) of Cambodia in 2006 to that in 2007?
Offer a very short reply. 0.66. What is the ratio of the Growth rate (annual %) in Hungary in 2006 to that in 2007?
Offer a terse response. 1.25. What is the ratio of the Growth rate (annual %) in Moldova in 2006 to that in 2007?
Your answer should be compact. 0.59. What is the ratio of the Growth rate (annual %) of Cambodia in 2006 to that in 2008?
Offer a terse response. 7.45. What is the ratio of the Growth rate (annual %) of Hungary in 2006 to that in 2008?
Your response must be concise. 1.58. What is the ratio of the Growth rate (annual %) in Moldova in 2006 to that in 2008?
Make the answer very short. 1.49. What is the ratio of the Growth rate (annual %) of Cambodia in 2006 to that in 2009?
Your answer should be very brief. 1.14. What is the ratio of the Growth rate (annual %) of Hungary in 2006 to that in 2009?
Your answer should be very brief. 3.78. What is the ratio of the Growth rate (annual %) of Moldova in 2006 to that in 2009?
Your answer should be compact. 7.44. What is the ratio of the Growth rate (annual %) in Cambodia in 2006 to that in 2010?
Provide a short and direct response. 1.9. What is the ratio of the Growth rate (annual %) of Hungary in 2006 to that in 2010?
Your answer should be very brief. 3.23. What is the ratio of the Growth rate (annual %) of Moldova in 2006 to that in 2010?
Ensure brevity in your answer.  1.73. What is the ratio of the Growth rate (annual %) in Cambodia in 2007 to that in 2008?
Make the answer very short. 11.35. What is the ratio of the Growth rate (annual %) of Hungary in 2007 to that in 2008?
Your answer should be very brief. 1.26. What is the ratio of the Growth rate (annual %) in Moldova in 2007 to that in 2008?
Your response must be concise. 2.51. What is the ratio of the Growth rate (annual %) in Cambodia in 2007 to that in 2009?
Keep it short and to the point. 1.74. What is the ratio of the Growth rate (annual %) in Hungary in 2007 to that in 2009?
Your response must be concise. 3.02. What is the ratio of the Growth rate (annual %) of Moldova in 2007 to that in 2009?
Your answer should be very brief. 12.57. What is the ratio of the Growth rate (annual %) in Cambodia in 2007 to that in 2010?
Make the answer very short. 2.9. What is the ratio of the Growth rate (annual %) of Hungary in 2007 to that in 2010?
Provide a succinct answer. 2.58. What is the ratio of the Growth rate (annual %) in Moldova in 2007 to that in 2010?
Your response must be concise. 2.92. What is the ratio of the Growth rate (annual %) of Cambodia in 2008 to that in 2009?
Provide a short and direct response. 0.15. What is the ratio of the Growth rate (annual %) in Hungary in 2008 to that in 2009?
Keep it short and to the point. 2.39. What is the ratio of the Growth rate (annual %) in Moldova in 2008 to that in 2009?
Make the answer very short. 5.01. What is the ratio of the Growth rate (annual %) of Cambodia in 2008 to that in 2010?
Keep it short and to the point. 0.26. What is the ratio of the Growth rate (annual %) in Hungary in 2008 to that in 2010?
Keep it short and to the point. 2.04. What is the ratio of the Growth rate (annual %) in Moldova in 2008 to that in 2010?
Offer a terse response. 1.16. What is the ratio of the Growth rate (annual %) of Cambodia in 2009 to that in 2010?
Make the answer very short. 1.67. What is the ratio of the Growth rate (annual %) in Hungary in 2009 to that in 2010?
Ensure brevity in your answer.  0.85. What is the ratio of the Growth rate (annual %) of Moldova in 2009 to that in 2010?
Make the answer very short. 0.23. What is the difference between the highest and the second highest Growth rate (annual %) of Cambodia?
Your answer should be compact. 21.29. What is the difference between the highest and the second highest Growth rate (annual %) of Hungary?
Your answer should be compact. 0.9. What is the difference between the highest and the second highest Growth rate (annual %) of Moldova?
Offer a very short reply. 1.69. What is the difference between the highest and the lowest Growth rate (annual %) in Cambodia?
Your answer should be very brief. 56.39. What is the difference between the highest and the lowest Growth rate (annual %) of Hungary?
Your response must be concise. 11.05. What is the difference between the highest and the lowest Growth rate (annual %) of Moldova?
Provide a succinct answer. 36.64. 